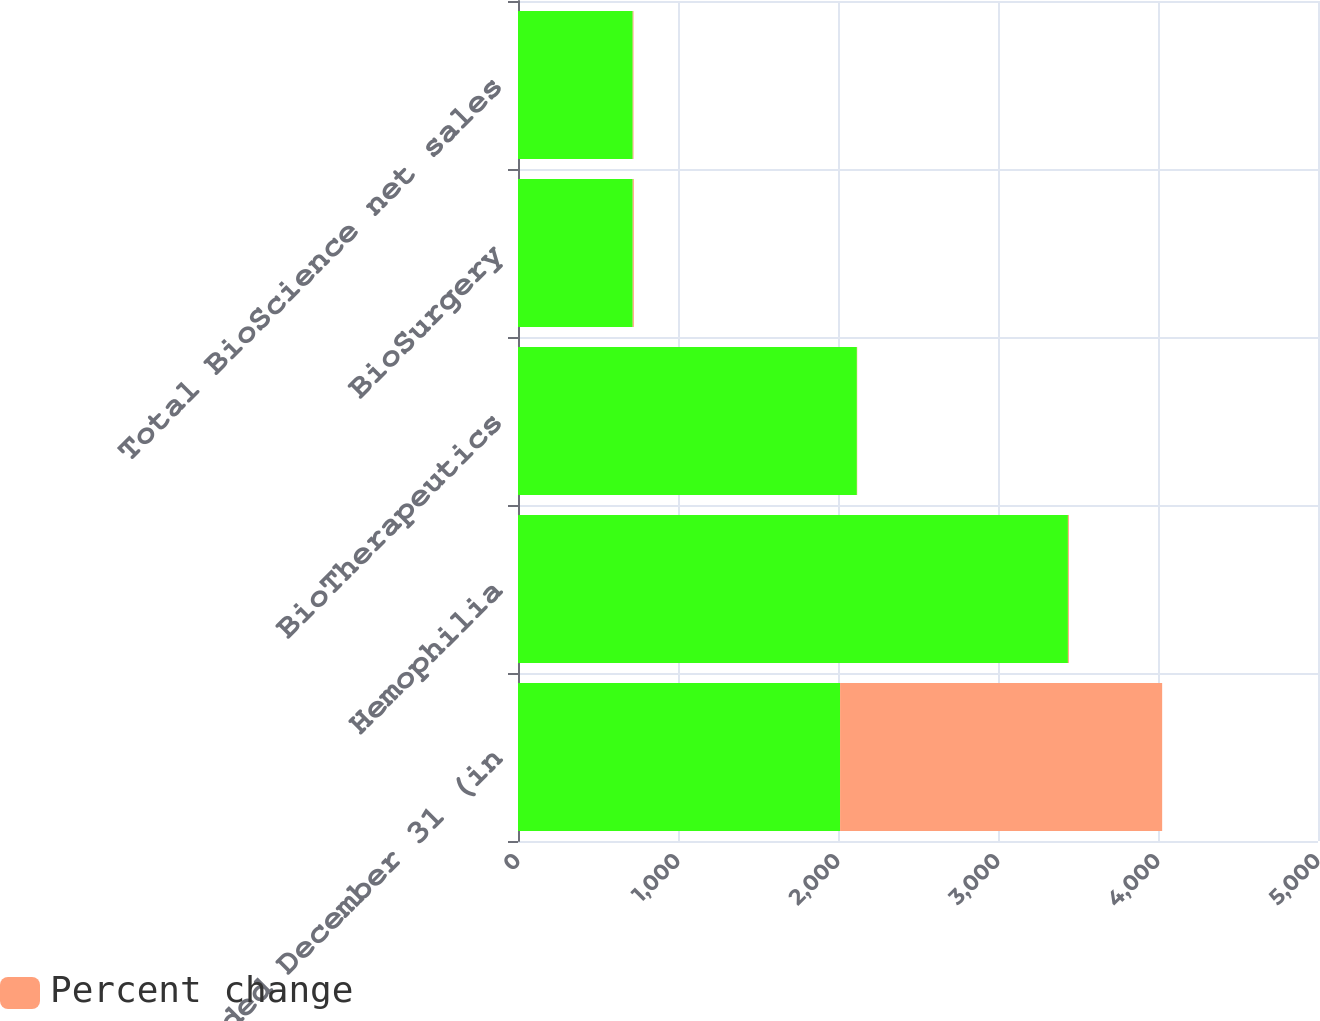Convert chart to OTSL. <chart><loc_0><loc_0><loc_500><loc_500><stacked_bar_chart><ecel><fcel>years ended December 31 (in<fcel>Hemophilia<fcel>BioTherapeutics<fcel>BioSurgery<fcel>Total BioScience net sales<nl><fcel>nan<fcel>2013<fcel>3437<fcel>2118<fcel>717<fcel>717<nl><fcel>Percent change<fcel>2013<fcel>6<fcel>2<fcel>7<fcel>5<nl></chart> 